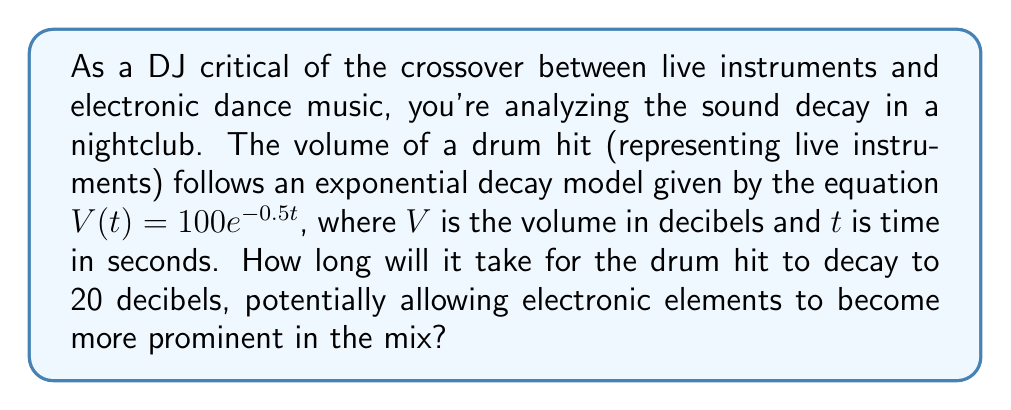Can you answer this question? To solve this problem, we need to use the exponential decay equation and solve for t when V(t) = 20 decibels.

Given equation: $V(t) = 100e^{-0.5t}$

1. Substitute V(t) with 20:
   $20 = 100e^{-0.5t}$

2. Divide both sides by 100:
   $\frac{20}{100} = e^{-0.5t}$
   $0.2 = e^{-0.5t}$

3. Take the natural logarithm of both sides:
   $\ln(0.2) = \ln(e^{-0.5t})$
   $\ln(0.2) = -0.5t$

4. Divide both sides by -0.5:
   $\frac{\ln(0.2)}{-0.5} = t$

5. Calculate the result:
   $t = -\frac{\ln(0.2)}{0.5} \approx 3.22$ seconds

Therefore, it will take approximately 3.22 seconds for the drum hit to decay to 20 decibels.
Answer: $t \approx 3.22$ seconds 